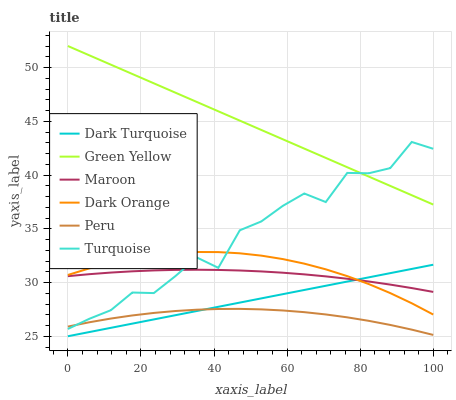Does Turquoise have the minimum area under the curve?
Answer yes or no. No. Does Turquoise have the maximum area under the curve?
Answer yes or no. No. Is Turquoise the smoothest?
Answer yes or no. No. Is Dark Turquoise the roughest?
Answer yes or no. No. Does Turquoise have the lowest value?
Answer yes or no. No. Does Turquoise have the highest value?
Answer yes or no. No. Is Dark Orange less than Green Yellow?
Answer yes or no. Yes. Is Green Yellow greater than Peru?
Answer yes or no. Yes. Does Dark Orange intersect Green Yellow?
Answer yes or no. No. 